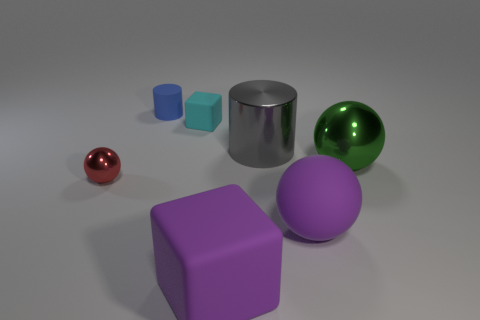Does the red shiny thing have the same size as the blue rubber thing?
Offer a terse response. Yes. What is the tiny cube made of?
Your response must be concise. Rubber. There is a sphere that is the same color as the large rubber block; what is its material?
Offer a terse response. Rubber. Does the purple rubber thing in front of the purple sphere have the same shape as the tiny cyan rubber thing?
Give a very brief answer. Yes. How many objects are small cyan rubber things or balls?
Your answer should be compact. 4. Is the material of the purple object that is left of the rubber ball the same as the tiny cube?
Provide a succinct answer. Yes. The gray metallic object is what size?
Give a very brief answer. Large. The big matte object that is the same color as the matte ball is what shape?
Ensure brevity in your answer.  Cube. How many balls are green shiny things or tiny metallic objects?
Your answer should be compact. 2. Are there an equal number of tiny balls that are on the right side of the big gray metallic cylinder and large spheres that are behind the big purple ball?
Your response must be concise. No. 